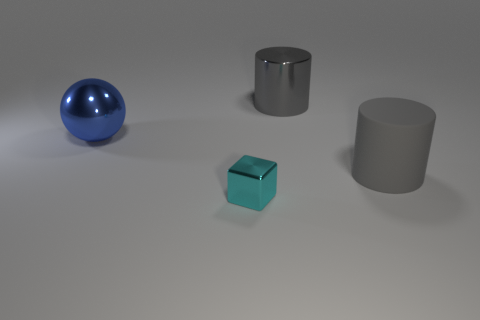Are there an equal number of large gray rubber cylinders on the right side of the small metallic cube and large gray cylinders on the left side of the blue metallic object?
Offer a terse response. No. The large shiny thing that is the same color as the rubber thing is what shape?
Offer a very short reply. Cylinder. What is the material of the gray cylinder in front of the blue sphere?
Your answer should be compact. Rubber. Do the blue metallic object and the gray metallic cylinder have the same size?
Offer a terse response. Yes. Are there more big shiny objects that are behind the large blue metal ball than large matte cubes?
Keep it short and to the point. Yes. The gray object that is the same material as the ball is what size?
Provide a short and direct response. Large. There is a tiny cyan metallic thing; are there any cyan metallic blocks behind it?
Your response must be concise. No. Is the shape of the cyan thing the same as the blue shiny thing?
Keep it short and to the point. No. There is a metallic object left of the block in front of the gray cylinder right of the big gray metal thing; what size is it?
Make the answer very short. Large. There is a metallic thing that is the same color as the rubber thing; what size is it?
Your answer should be very brief. Large. 